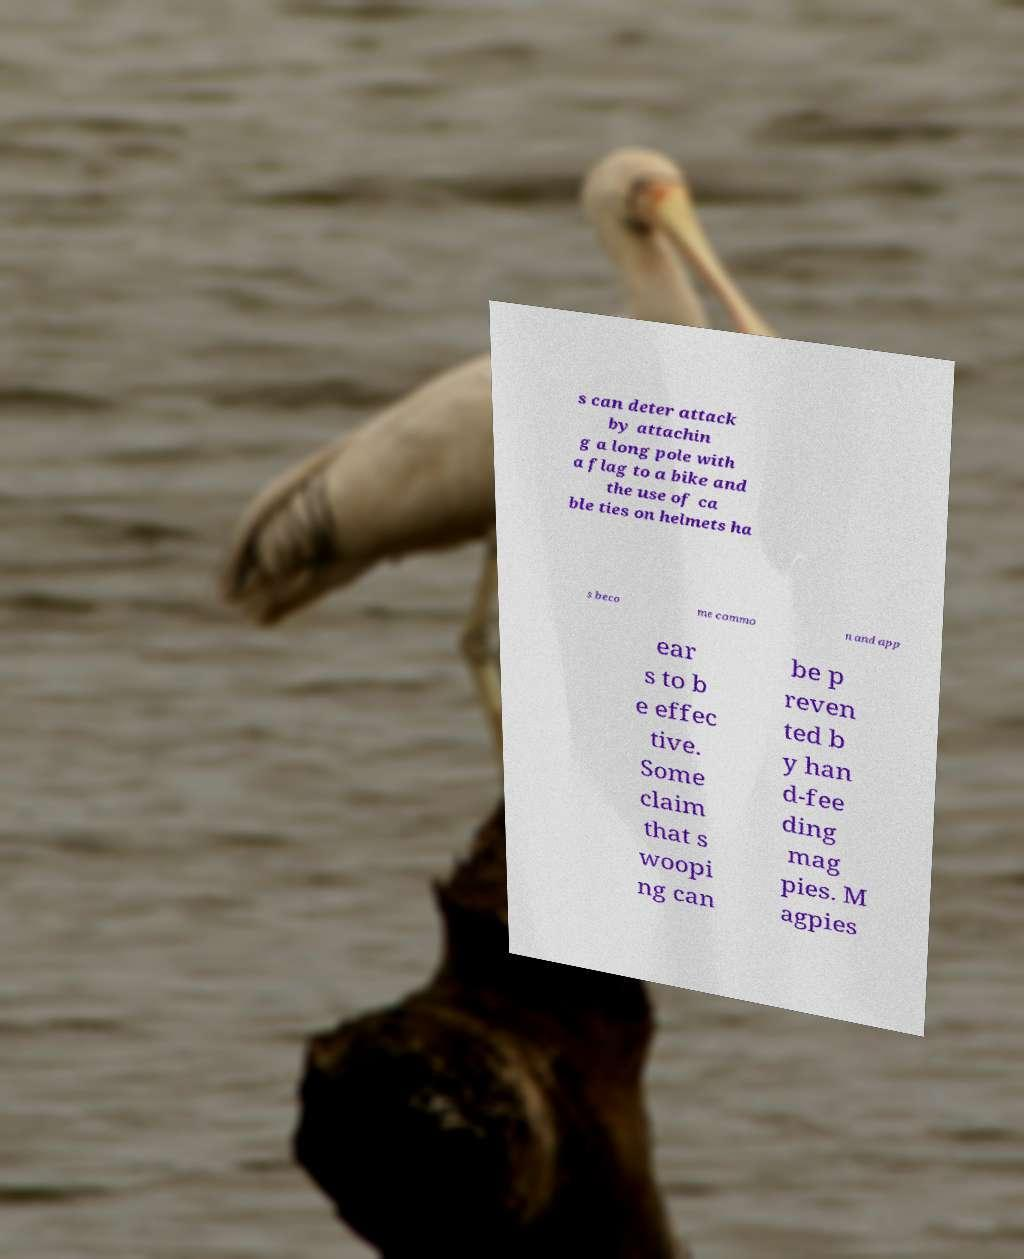Please read and relay the text visible in this image. What does it say? s can deter attack by attachin g a long pole with a flag to a bike and the use of ca ble ties on helmets ha s beco me commo n and app ear s to b e effec tive. Some claim that s woopi ng can be p reven ted b y han d-fee ding mag pies. M agpies 